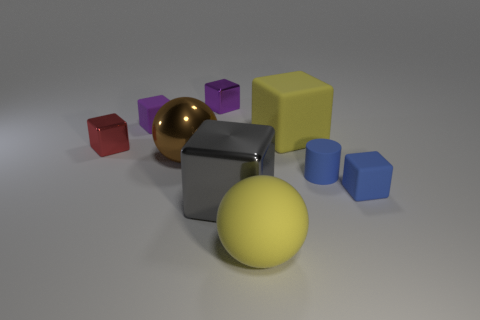Subtract all yellow cubes. How many cubes are left? 5 Subtract all small blue blocks. How many blocks are left? 5 Subtract all red cubes. Subtract all cyan balls. How many cubes are left? 5 Add 1 tiny red metal cylinders. How many objects exist? 10 Subtract all blocks. How many objects are left? 3 Subtract all small red cylinders. Subtract all red blocks. How many objects are left? 8 Add 9 tiny blue blocks. How many tiny blue blocks are left? 10 Add 2 big yellow matte cubes. How many big yellow matte cubes exist? 3 Subtract 0 blue spheres. How many objects are left? 9 